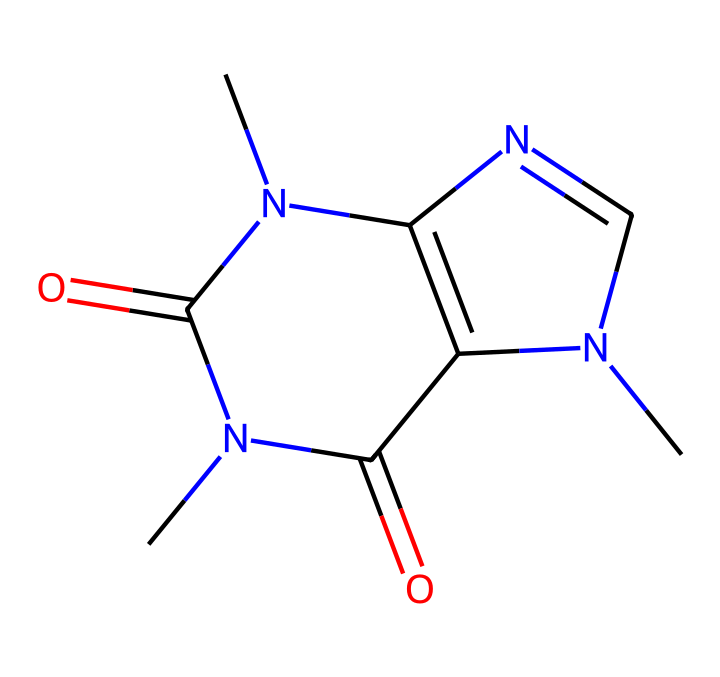What is the name of this chemical? The SMILES representation corresponds to caffeine, which is a well-known stimulant. This is determined by comparing the structure and its known properties with standard chemical databases.
Answer: caffeine How many nitrogen atoms are present in this structure? By analyzing the SMILES representation, you can count the nitrogen atoms (N). There are three nitrogen atoms in the structure, indicated by the N symbols in the SMILES.
Answer: three What type of compound is caffeine classified as? Caffeine is classified as an alkaloid, which is a type of nitrogen-containing compound derived from plants and known for its pharmacological effects. The presence of nitrogen and the overall structure confirm this classification.
Answer: alkaloid What is the number of carbon atoms in this structure? Counting the carbon atoms present in the SMILES representation (C), you find a total of eight carbon atoms in caffeine. Each 'C' corresponds to a carbon atom in the molecular structure.
Answer: eight What are the functional groups present in caffeine? The key functional groups present in caffeine include the imine (due to the carbon-nitrogen double bonds) and amide functional groups (due to the carbonyl adjacent to nitrogen). This is determined by analyzing the connectivity and arrangement of the atoms in the structure.
Answer: imine and amide Which part of the chemical structure contributes to its stimulant properties? The presence of three nitrogen atoms and specific structural arrangements, such as the methyl groups attached to these nitrogens, play a crucial role in its stimulant properties by interacting with adenosine receptors in the brain. This can be reasoned by understanding the biological interactions caffeine undergoes.
Answer: nitrogen atoms and methyl groups What is the molecular formula of caffeine? The molecular formula can be derived from the SMILES representation: C8H10N4O2. This involves counting the atoms of each type (carbon, hydrogen, nitrogen, and oxygen) from the structure represented in SMILES.
Answer: C8H10N4O2 